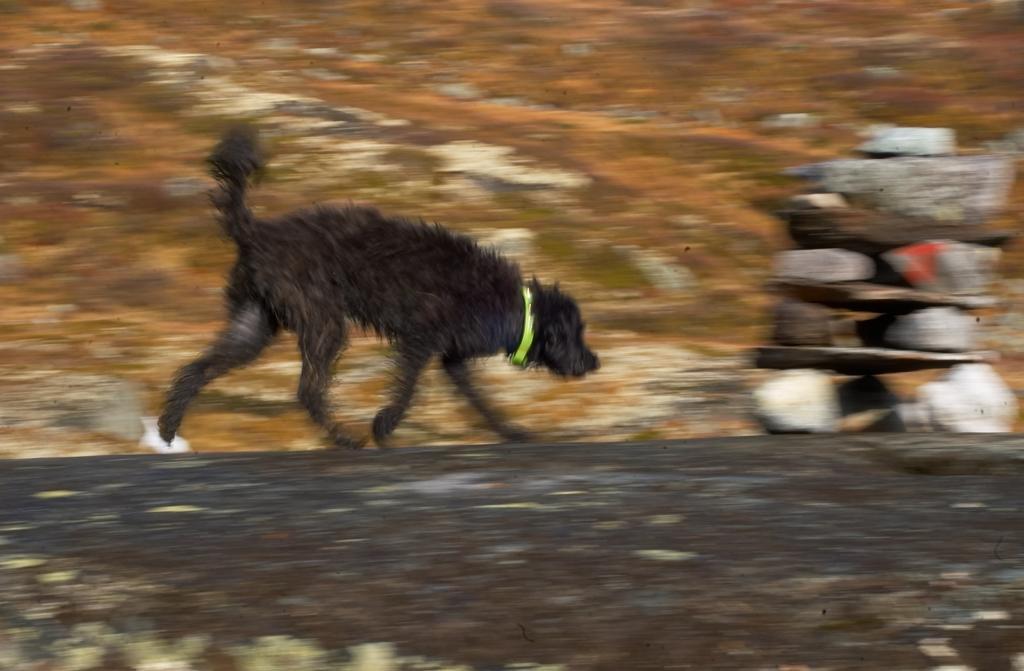Please provide a concise description of this image. In this picture there is a dog running and there are few rocks placed on top of each other and there are some other objects in the background. 